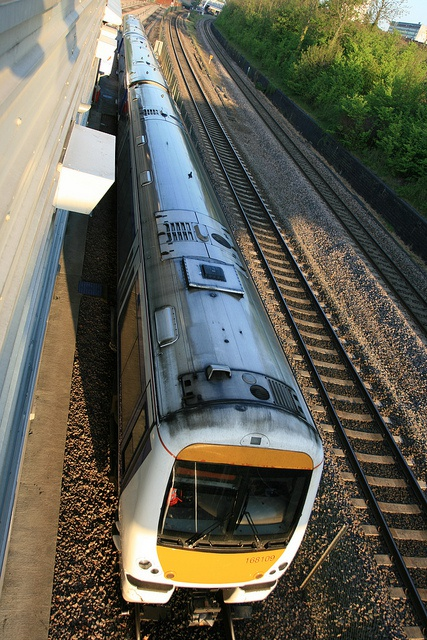Describe the objects in this image and their specific colors. I can see a train in gray, black, lightblue, and white tones in this image. 